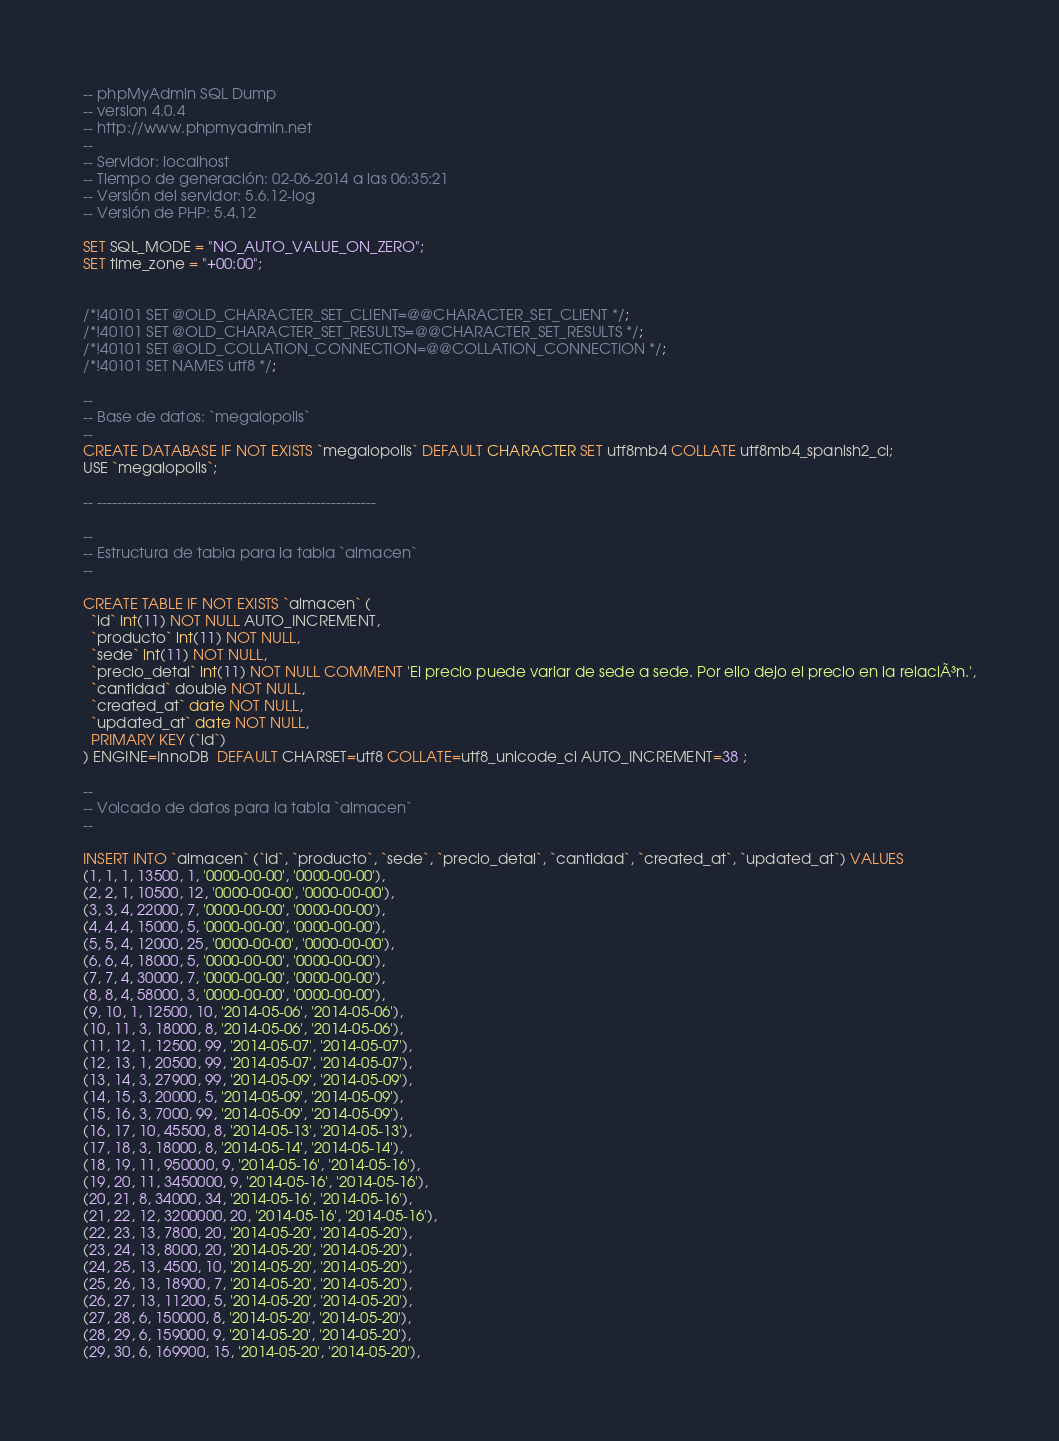Convert code to text. <code><loc_0><loc_0><loc_500><loc_500><_SQL_>-- phpMyAdmin SQL Dump
-- version 4.0.4
-- http://www.phpmyadmin.net
--
-- Servidor: localhost
-- Tiempo de generación: 02-06-2014 a las 06:35:21
-- Versión del servidor: 5.6.12-log
-- Versión de PHP: 5.4.12

SET SQL_MODE = "NO_AUTO_VALUE_ON_ZERO";
SET time_zone = "+00:00";


/*!40101 SET @OLD_CHARACTER_SET_CLIENT=@@CHARACTER_SET_CLIENT */;
/*!40101 SET @OLD_CHARACTER_SET_RESULTS=@@CHARACTER_SET_RESULTS */;
/*!40101 SET @OLD_COLLATION_CONNECTION=@@COLLATION_CONNECTION */;
/*!40101 SET NAMES utf8 */;

--
-- Base de datos: `megalopolis`
--
CREATE DATABASE IF NOT EXISTS `megalopolis` DEFAULT CHARACTER SET utf8mb4 COLLATE utf8mb4_spanish2_ci;
USE `megalopolis`;

-- --------------------------------------------------------

--
-- Estructura de tabla para la tabla `almacen`
--

CREATE TABLE IF NOT EXISTS `almacen` (
  `id` int(11) NOT NULL AUTO_INCREMENT,
  `producto` int(11) NOT NULL,
  `sede` int(11) NOT NULL,
  `precio_detal` int(11) NOT NULL COMMENT 'El precio puede variar de sede a sede. Por ello dejo el precio en la relaciÃ³n.',
  `cantidad` double NOT NULL,
  `created_at` date NOT NULL,
  `updated_at` date NOT NULL,
  PRIMARY KEY (`id`)
) ENGINE=InnoDB  DEFAULT CHARSET=utf8 COLLATE=utf8_unicode_ci AUTO_INCREMENT=38 ;

--
-- Volcado de datos para la tabla `almacen`
--

INSERT INTO `almacen` (`id`, `producto`, `sede`, `precio_detal`, `cantidad`, `created_at`, `updated_at`) VALUES
(1, 1, 1, 13500, 1, '0000-00-00', '0000-00-00'),
(2, 2, 1, 10500, 12, '0000-00-00', '0000-00-00'),
(3, 3, 4, 22000, 7, '0000-00-00', '0000-00-00'),
(4, 4, 4, 15000, 5, '0000-00-00', '0000-00-00'),
(5, 5, 4, 12000, 25, '0000-00-00', '0000-00-00'),
(6, 6, 4, 18000, 5, '0000-00-00', '0000-00-00'),
(7, 7, 4, 30000, 7, '0000-00-00', '0000-00-00'),
(8, 8, 4, 58000, 3, '0000-00-00', '0000-00-00'),
(9, 10, 1, 12500, 10, '2014-05-06', '2014-05-06'),
(10, 11, 3, 18000, 8, '2014-05-06', '2014-05-06'),
(11, 12, 1, 12500, 99, '2014-05-07', '2014-05-07'),
(12, 13, 1, 20500, 99, '2014-05-07', '2014-05-07'),
(13, 14, 3, 27900, 99, '2014-05-09', '2014-05-09'),
(14, 15, 3, 20000, 5, '2014-05-09', '2014-05-09'),
(15, 16, 3, 7000, 99, '2014-05-09', '2014-05-09'),
(16, 17, 10, 45500, 8, '2014-05-13', '2014-05-13'),
(17, 18, 3, 18000, 8, '2014-05-14', '2014-05-14'),
(18, 19, 11, 950000, 9, '2014-05-16', '2014-05-16'),
(19, 20, 11, 3450000, 9, '2014-05-16', '2014-05-16'),
(20, 21, 8, 34000, 34, '2014-05-16', '2014-05-16'),
(21, 22, 12, 3200000, 20, '2014-05-16', '2014-05-16'),
(22, 23, 13, 7800, 20, '2014-05-20', '2014-05-20'),
(23, 24, 13, 8000, 20, '2014-05-20', '2014-05-20'),
(24, 25, 13, 4500, 10, '2014-05-20', '2014-05-20'),
(25, 26, 13, 18900, 7, '2014-05-20', '2014-05-20'),
(26, 27, 13, 11200, 5, '2014-05-20', '2014-05-20'),
(27, 28, 6, 150000, 8, '2014-05-20', '2014-05-20'),
(28, 29, 6, 159000, 9, '2014-05-20', '2014-05-20'),
(29, 30, 6, 169900, 15, '2014-05-20', '2014-05-20'),</code> 